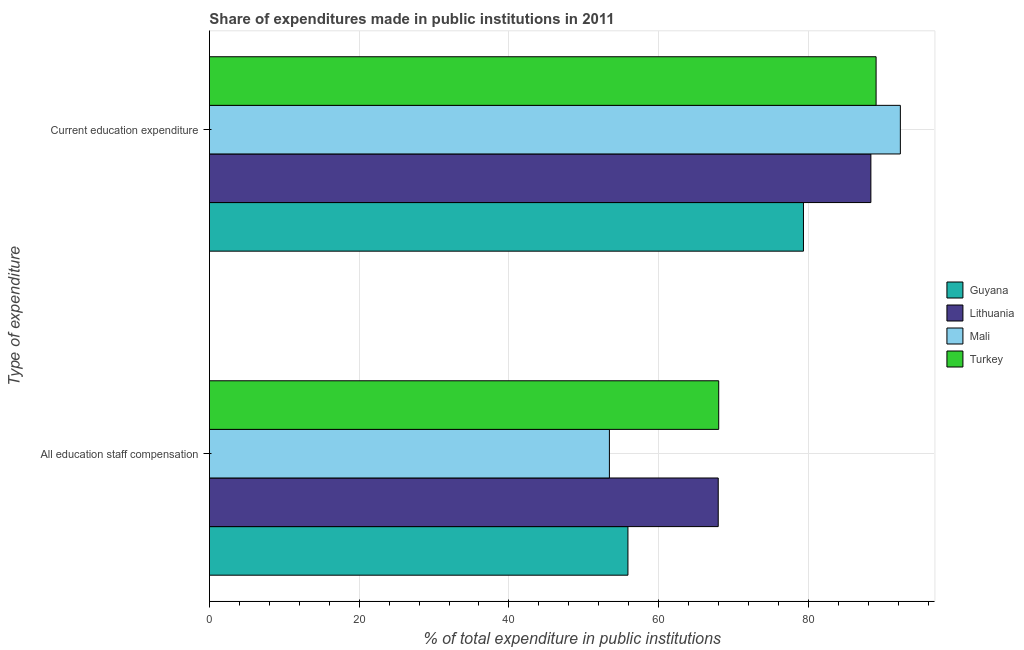Are the number of bars on each tick of the Y-axis equal?
Offer a terse response. Yes. What is the label of the 1st group of bars from the top?
Your answer should be compact. Current education expenditure. What is the expenditure in staff compensation in Mali?
Give a very brief answer. 53.42. Across all countries, what is the maximum expenditure in education?
Your answer should be very brief. 92.28. Across all countries, what is the minimum expenditure in education?
Your response must be concise. 79.34. In which country was the expenditure in staff compensation maximum?
Keep it short and to the point. Turkey. In which country was the expenditure in education minimum?
Provide a short and direct response. Guyana. What is the total expenditure in education in the graph?
Your answer should be very brief. 349. What is the difference between the expenditure in education in Mali and that in Guyana?
Keep it short and to the point. 12.94. What is the difference between the expenditure in education in Mali and the expenditure in staff compensation in Lithuania?
Keep it short and to the point. 24.33. What is the average expenditure in education per country?
Provide a short and direct response. 87.25. What is the difference between the expenditure in staff compensation and expenditure in education in Lithuania?
Your answer should be compact. -20.39. What is the ratio of the expenditure in staff compensation in Turkey to that in Mali?
Give a very brief answer. 1.27. Is the expenditure in education in Turkey less than that in Lithuania?
Make the answer very short. No. What does the 2nd bar from the top in Current education expenditure represents?
Make the answer very short. Mali. What does the 2nd bar from the bottom in All education staff compensation represents?
Ensure brevity in your answer.  Lithuania. Are all the bars in the graph horizontal?
Make the answer very short. Yes. Are the values on the major ticks of X-axis written in scientific E-notation?
Offer a terse response. No. Where does the legend appear in the graph?
Offer a terse response. Center right. How are the legend labels stacked?
Your answer should be compact. Vertical. What is the title of the graph?
Make the answer very short. Share of expenditures made in public institutions in 2011. Does "Virgin Islands" appear as one of the legend labels in the graph?
Offer a very short reply. No. What is the label or title of the X-axis?
Offer a terse response. % of total expenditure in public institutions. What is the label or title of the Y-axis?
Your answer should be compact. Type of expenditure. What is the % of total expenditure in public institutions in Guyana in All education staff compensation?
Your response must be concise. 55.9. What is the % of total expenditure in public institutions in Lithuania in All education staff compensation?
Keep it short and to the point. 67.96. What is the % of total expenditure in public institutions of Mali in All education staff compensation?
Your response must be concise. 53.42. What is the % of total expenditure in public institutions of Turkey in All education staff compensation?
Your answer should be compact. 68.02. What is the % of total expenditure in public institutions in Guyana in Current education expenditure?
Provide a short and direct response. 79.34. What is the % of total expenditure in public institutions in Lithuania in Current education expenditure?
Offer a terse response. 88.34. What is the % of total expenditure in public institutions in Mali in Current education expenditure?
Your answer should be very brief. 92.28. What is the % of total expenditure in public institutions of Turkey in Current education expenditure?
Your response must be concise. 89.04. Across all Type of expenditure, what is the maximum % of total expenditure in public institutions of Guyana?
Give a very brief answer. 79.34. Across all Type of expenditure, what is the maximum % of total expenditure in public institutions of Lithuania?
Offer a very short reply. 88.34. Across all Type of expenditure, what is the maximum % of total expenditure in public institutions in Mali?
Make the answer very short. 92.28. Across all Type of expenditure, what is the maximum % of total expenditure in public institutions in Turkey?
Your answer should be very brief. 89.04. Across all Type of expenditure, what is the minimum % of total expenditure in public institutions of Guyana?
Your answer should be compact. 55.9. Across all Type of expenditure, what is the minimum % of total expenditure in public institutions in Lithuania?
Make the answer very short. 67.96. Across all Type of expenditure, what is the minimum % of total expenditure in public institutions of Mali?
Ensure brevity in your answer.  53.42. Across all Type of expenditure, what is the minimum % of total expenditure in public institutions in Turkey?
Make the answer very short. 68.02. What is the total % of total expenditure in public institutions in Guyana in the graph?
Keep it short and to the point. 135.23. What is the total % of total expenditure in public institutions of Lithuania in the graph?
Your response must be concise. 156.3. What is the total % of total expenditure in public institutions of Mali in the graph?
Your answer should be compact. 145.7. What is the total % of total expenditure in public institutions in Turkey in the graph?
Your response must be concise. 157.06. What is the difference between the % of total expenditure in public institutions of Guyana in All education staff compensation and that in Current education expenditure?
Ensure brevity in your answer.  -23.44. What is the difference between the % of total expenditure in public institutions in Lithuania in All education staff compensation and that in Current education expenditure?
Give a very brief answer. -20.39. What is the difference between the % of total expenditure in public institutions of Mali in All education staff compensation and that in Current education expenditure?
Give a very brief answer. -38.86. What is the difference between the % of total expenditure in public institutions of Turkey in All education staff compensation and that in Current education expenditure?
Keep it short and to the point. -21.02. What is the difference between the % of total expenditure in public institutions in Guyana in All education staff compensation and the % of total expenditure in public institutions in Lithuania in Current education expenditure?
Your answer should be compact. -32.45. What is the difference between the % of total expenditure in public institutions in Guyana in All education staff compensation and the % of total expenditure in public institutions in Mali in Current education expenditure?
Your response must be concise. -36.38. What is the difference between the % of total expenditure in public institutions of Guyana in All education staff compensation and the % of total expenditure in public institutions of Turkey in Current education expenditure?
Offer a very short reply. -33.14. What is the difference between the % of total expenditure in public institutions in Lithuania in All education staff compensation and the % of total expenditure in public institutions in Mali in Current education expenditure?
Offer a very short reply. -24.33. What is the difference between the % of total expenditure in public institutions in Lithuania in All education staff compensation and the % of total expenditure in public institutions in Turkey in Current education expenditure?
Make the answer very short. -21.08. What is the difference between the % of total expenditure in public institutions in Mali in All education staff compensation and the % of total expenditure in public institutions in Turkey in Current education expenditure?
Provide a short and direct response. -35.62. What is the average % of total expenditure in public institutions in Guyana per Type of expenditure?
Offer a very short reply. 67.62. What is the average % of total expenditure in public institutions in Lithuania per Type of expenditure?
Provide a short and direct response. 78.15. What is the average % of total expenditure in public institutions of Mali per Type of expenditure?
Offer a terse response. 72.85. What is the average % of total expenditure in public institutions in Turkey per Type of expenditure?
Your answer should be very brief. 78.53. What is the difference between the % of total expenditure in public institutions of Guyana and % of total expenditure in public institutions of Lithuania in All education staff compensation?
Ensure brevity in your answer.  -12.06. What is the difference between the % of total expenditure in public institutions of Guyana and % of total expenditure in public institutions of Mali in All education staff compensation?
Make the answer very short. 2.48. What is the difference between the % of total expenditure in public institutions of Guyana and % of total expenditure in public institutions of Turkey in All education staff compensation?
Provide a short and direct response. -12.12. What is the difference between the % of total expenditure in public institutions in Lithuania and % of total expenditure in public institutions in Mali in All education staff compensation?
Offer a terse response. 14.53. What is the difference between the % of total expenditure in public institutions in Lithuania and % of total expenditure in public institutions in Turkey in All education staff compensation?
Offer a terse response. -0.07. What is the difference between the % of total expenditure in public institutions in Mali and % of total expenditure in public institutions in Turkey in All education staff compensation?
Make the answer very short. -14.6. What is the difference between the % of total expenditure in public institutions in Guyana and % of total expenditure in public institutions in Lithuania in Current education expenditure?
Your answer should be very brief. -9.01. What is the difference between the % of total expenditure in public institutions of Guyana and % of total expenditure in public institutions of Mali in Current education expenditure?
Offer a terse response. -12.94. What is the difference between the % of total expenditure in public institutions of Guyana and % of total expenditure in public institutions of Turkey in Current education expenditure?
Offer a very short reply. -9.7. What is the difference between the % of total expenditure in public institutions of Lithuania and % of total expenditure in public institutions of Mali in Current education expenditure?
Give a very brief answer. -3.94. What is the difference between the % of total expenditure in public institutions of Lithuania and % of total expenditure in public institutions of Turkey in Current education expenditure?
Make the answer very short. -0.7. What is the difference between the % of total expenditure in public institutions in Mali and % of total expenditure in public institutions in Turkey in Current education expenditure?
Give a very brief answer. 3.24. What is the ratio of the % of total expenditure in public institutions of Guyana in All education staff compensation to that in Current education expenditure?
Provide a succinct answer. 0.7. What is the ratio of the % of total expenditure in public institutions in Lithuania in All education staff compensation to that in Current education expenditure?
Provide a succinct answer. 0.77. What is the ratio of the % of total expenditure in public institutions in Mali in All education staff compensation to that in Current education expenditure?
Provide a short and direct response. 0.58. What is the ratio of the % of total expenditure in public institutions of Turkey in All education staff compensation to that in Current education expenditure?
Offer a very short reply. 0.76. What is the difference between the highest and the second highest % of total expenditure in public institutions of Guyana?
Your answer should be very brief. 23.44. What is the difference between the highest and the second highest % of total expenditure in public institutions in Lithuania?
Make the answer very short. 20.39. What is the difference between the highest and the second highest % of total expenditure in public institutions in Mali?
Make the answer very short. 38.86. What is the difference between the highest and the second highest % of total expenditure in public institutions of Turkey?
Your answer should be compact. 21.02. What is the difference between the highest and the lowest % of total expenditure in public institutions of Guyana?
Your answer should be compact. 23.44. What is the difference between the highest and the lowest % of total expenditure in public institutions in Lithuania?
Your answer should be compact. 20.39. What is the difference between the highest and the lowest % of total expenditure in public institutions in Mali?
Your answer should be very brief. 38.86. What is the difference between the highest and the lowest % of total expenditure in public institutions of Turkey?
Your answer should be very brief. 21.02. 